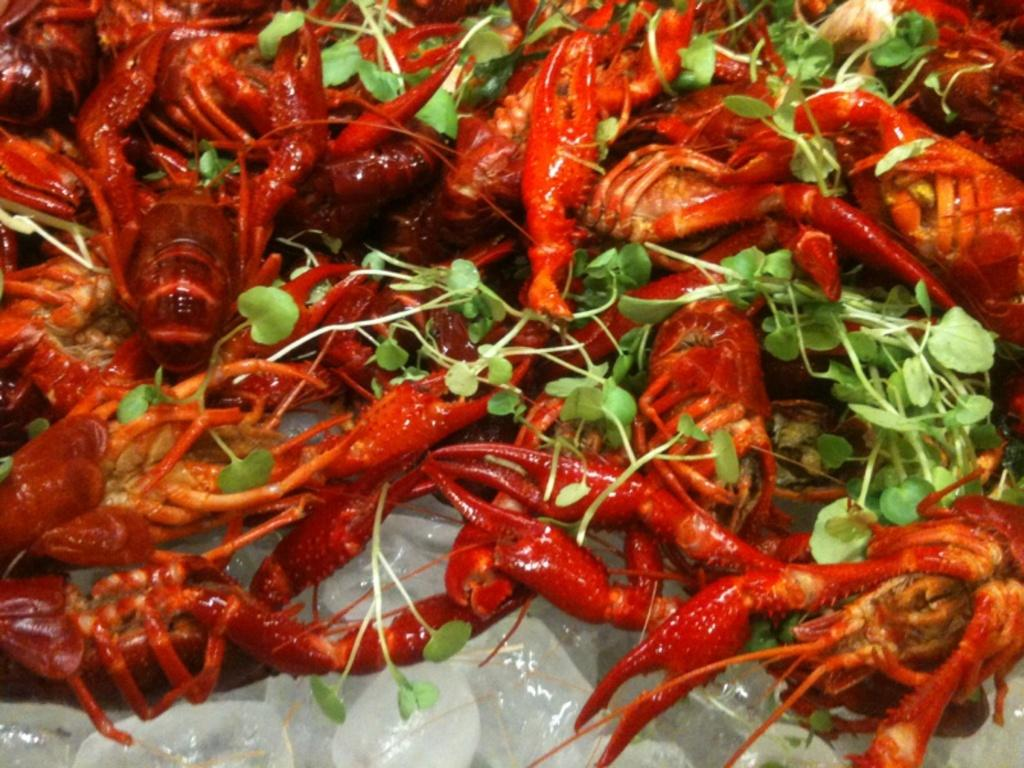What is the food placed on in the image? The food is placed on ice in the image. What type of topping is visible on the food? The food is topped with leafy vegetables. What type of wrist accessory is visible on the food in the image? There is no wrist accessory present on the food in the image. 